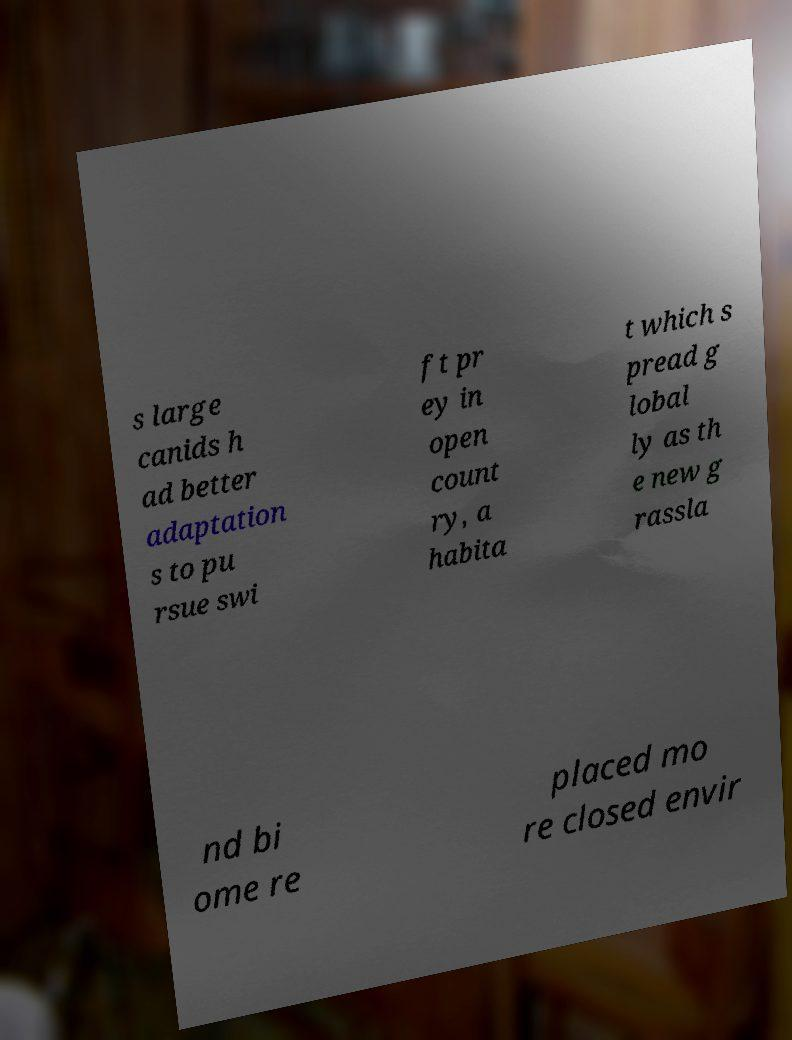Could you extract and type out the text from this image? s large canids h ad better adaptation s to pu rsue swi ft pr ey in open count ry, a habita t which s pread g lobal ly as th e new g rassla nd bi ome re placed mo re closed envir 